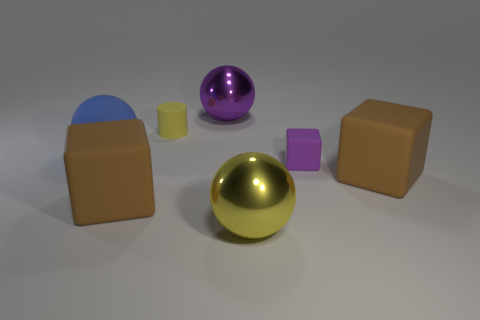Can you tell me what materials these objects might be made of based on their appearance? The objects have a smooth and reflective surface, which suggests they could be made of materials like polished metal or plastic with a metallic coating to give them that shiny appearance. 